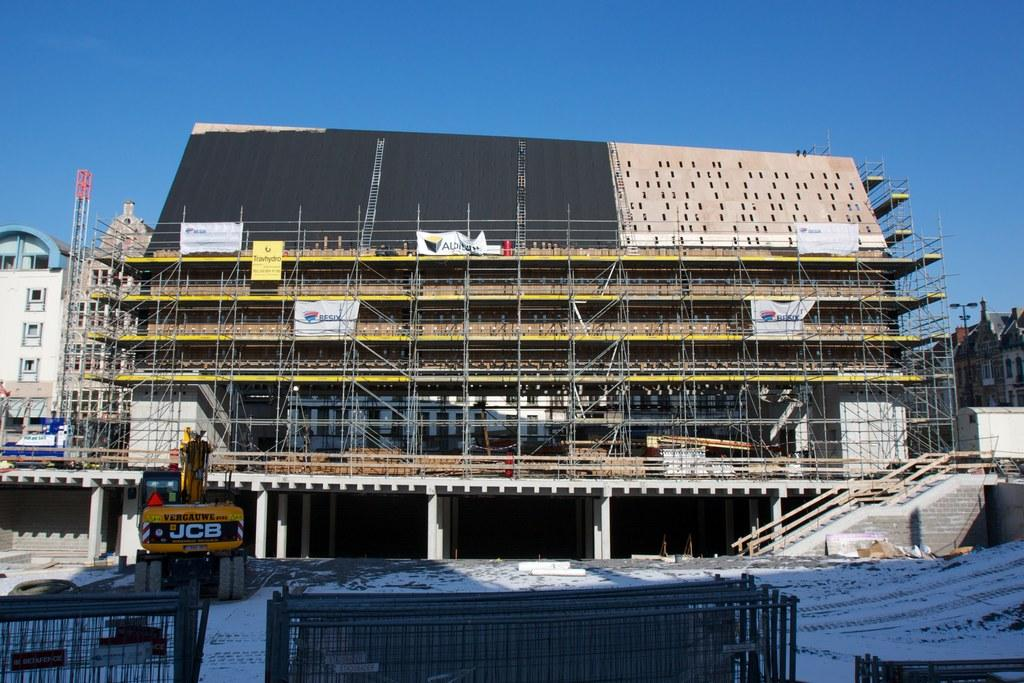What is the main subject of the image? The main subject of the image is a building under construction. Can you describe any other buildings in the image? Yes, there is a building visible in the image. What else can be seen in the image? There is a vehicle in the image. How does the building blow away in the image? The building does not blow away in the image; it is under construction. What type of knot is used to secure the building in the image? There is no knot present in the image, as knots are not used to secure buildings. --- 